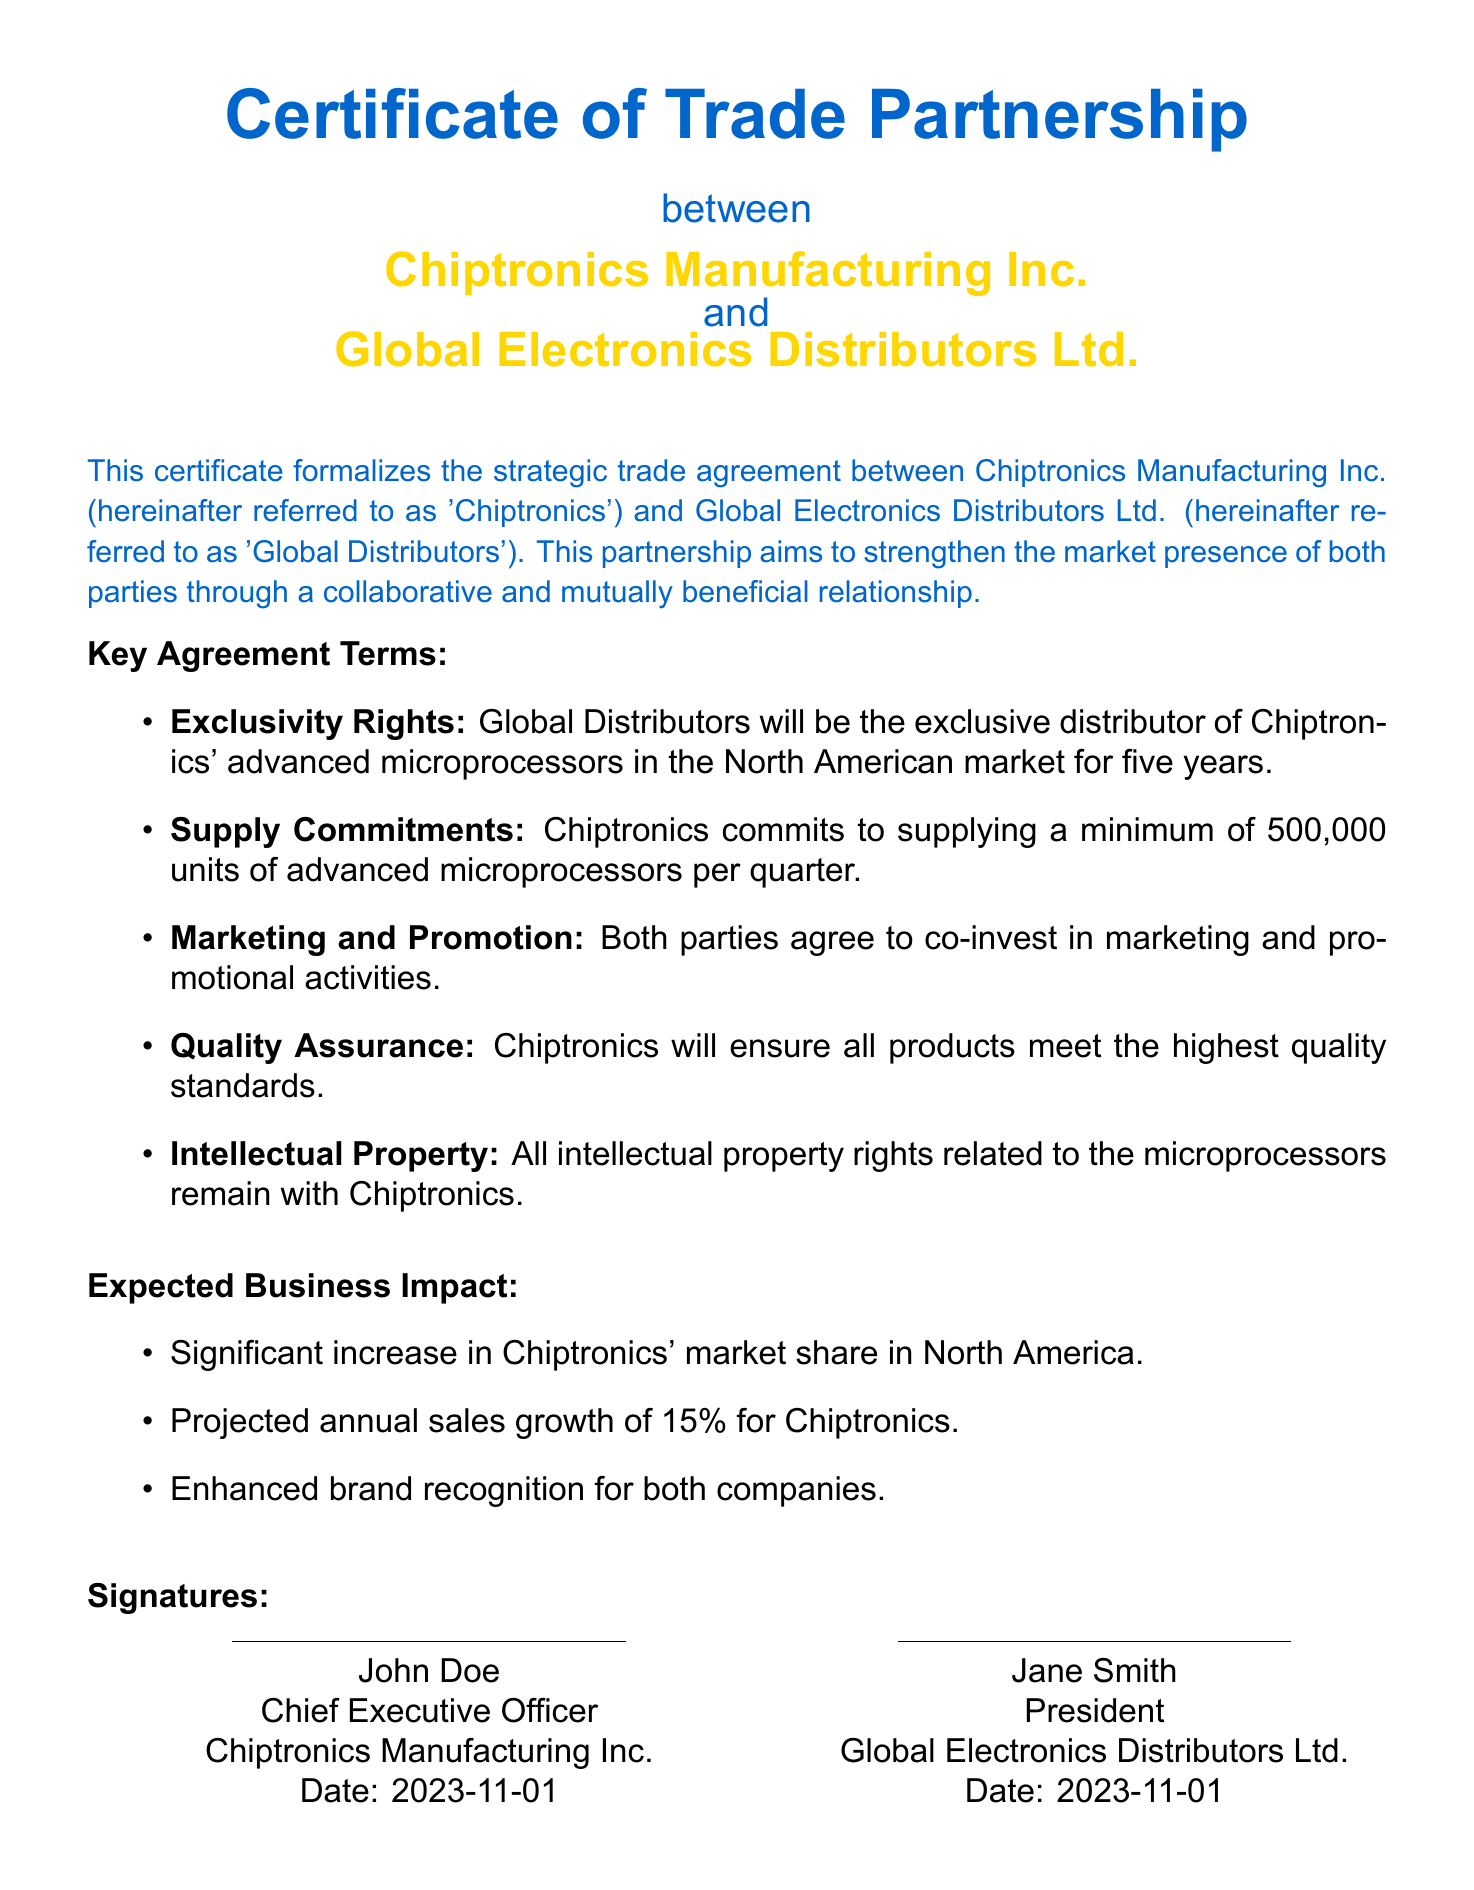What is the certificate titled? The title of the certificate is stated at the top of the document, "Certificate of Trade Partnership."
Answer: Certificate of Trade Partnership Who are the parties involved in this trade partnership? The parties involved are mentioned prominently in the document: Chiptronics Manufacturing Inc. and Global Electronics Distributors Ltd.
Answer: Chiptronics Manufacturing Inc. and Global Electronics Distributors Ltd What is the exclusivity period for Global Distributors? The document specifies that Global Distributors will have exclusivity for five years.
Answer: five years How many units of advanced microprocessors is Chiptronics committed to supplying per quarter? The supply commitment outlined specifies a minimum of 500,000 units per quarter.
Answer: 500,000 units What is the projected annual sales growth for Chiptronics? The document states the projected annual sales growth is 15%.
Answer: 15% What is retained by Chiptronics concerning intellectual property rights? The document clearly states that all intellectual property rights related to the microprocessors remain with Chiptronics.
Answer: Intellectual property rights What is the expected impact on Chiptronics' market share in North America? The document predicts a significant increase in Chiptronics' market share in North America.
Answer: Significant increase When was the certificate signed? The date of signing is indicated in the signatures section of the document, which is 2023-11-01.
Answer: 2023-11-01 What position does John Doe hold at Chiptronics? The document lists John Doe's title as Chief Executive Officer.
Answer: Chief Executive Officer 